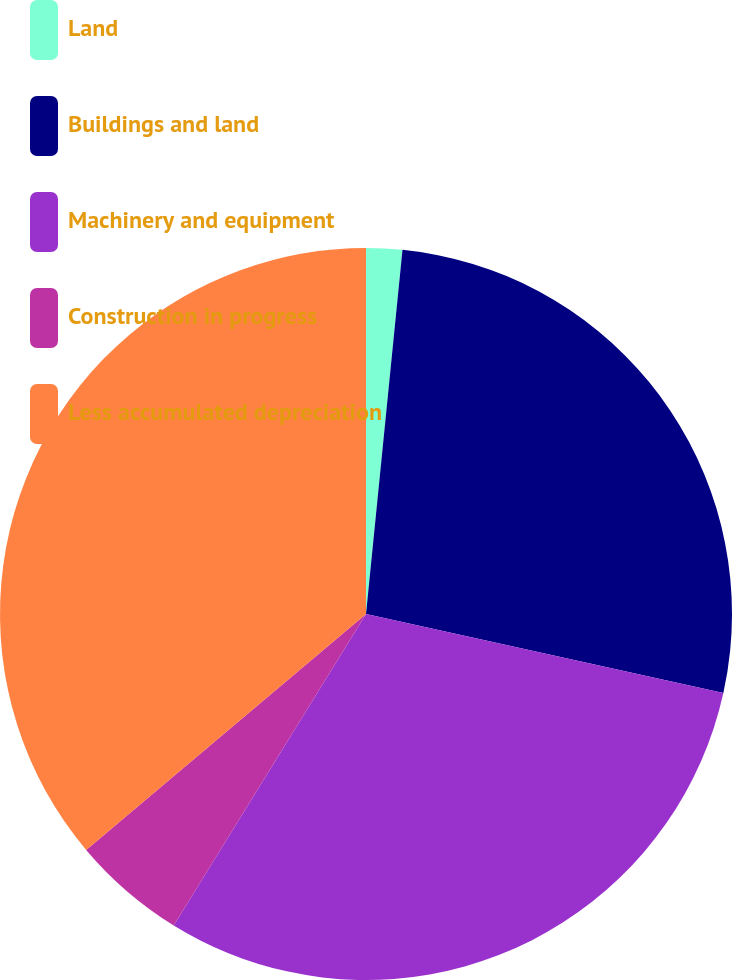Convert chart. <chart><loc_0><loc_0><loc_500><loc_500><pie_chart><fcel>Land<fcel>Buildings and land<fcel>Machinery and equipment<fcel>Construction in progress<fcel>Less accumulated depreciation<nl><fcel>1.59%<fcel>26.88%<fcel>30.34%<fcel>5.05%<fcel>36.15%<nl></chart> 